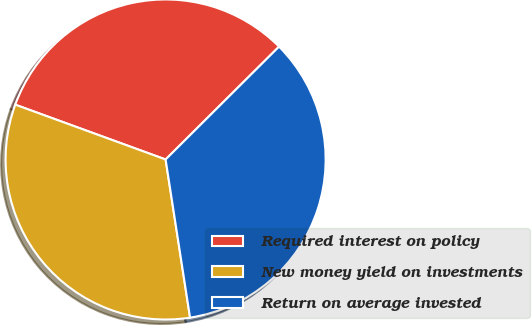<chart> <loc_0><loc_0><loc_500><loc_500><pie_chart><fcel>Required interest on policy<fcel>New money yield on investments<fcel>Return on average invested<nl><fcel>31.98%<fcel>33.01%<fcel>35.02%<nl></chart> 